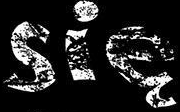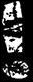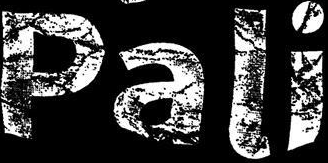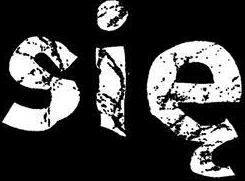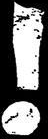Read the text from these images in sequence, separated by a semicolon. się; !; Pali; się; ! 